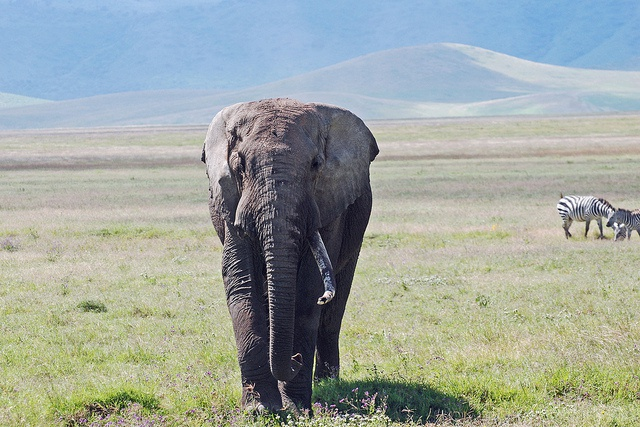Describe the objects in this image and their specific colors. I can see elephant in lightblue, black, gray, and darkgray tones, zebra in lightblue, gray, darkgray, lightgray, and black tones, and zebra in lightblue, gray, darkgray, and black tones in this image. 